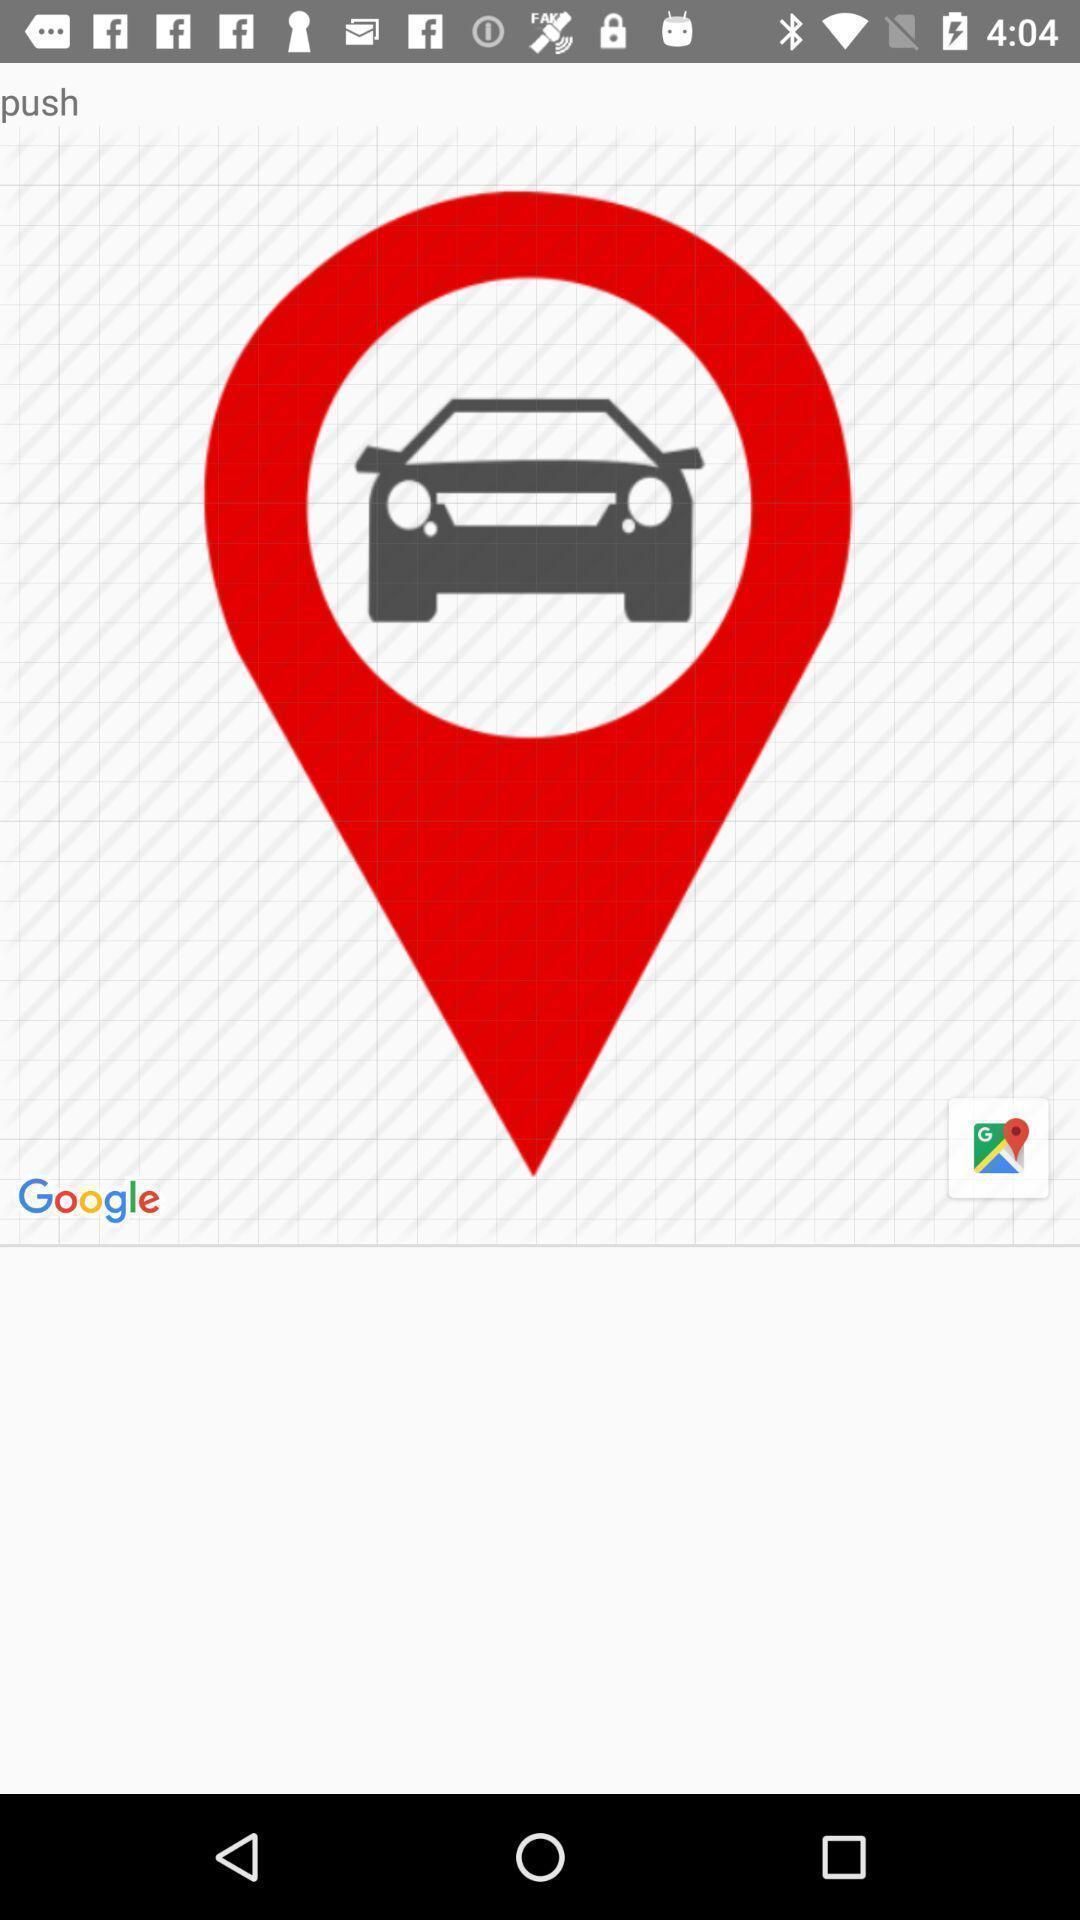Describe the key features of this screenshot. Screen displaying the navigation icon. 